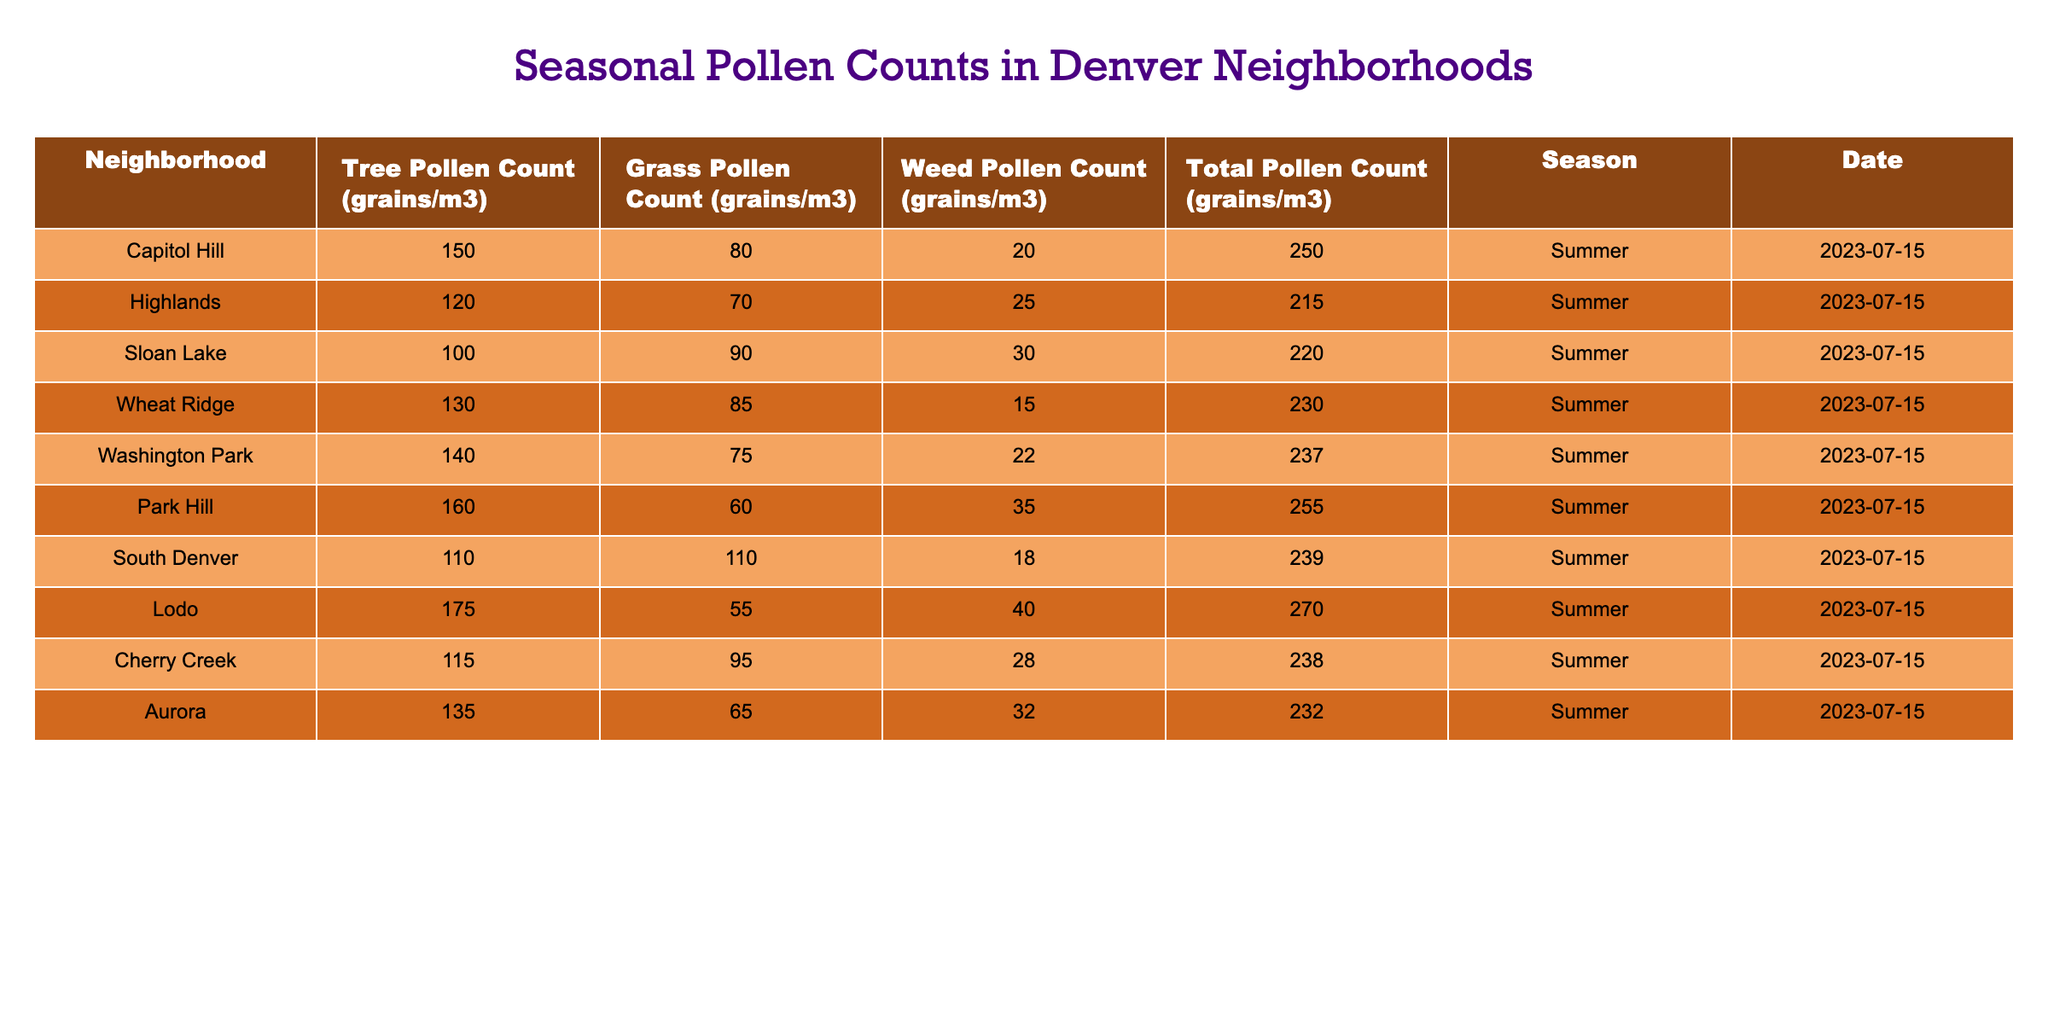What is the total pollen count for Park Hill? According to the table, the total pollen count for Park Hill is directly listed as 255 grains/m3.
Answer: 255 Which neighborhood has the highest tree pollen count? By checking the tree pollen counts in the table, Lodo has the highest count at 175 grains/m3.
Answer: Lodo What is the average total pollen count across all neighborhoods? To find the average total pollen count, first sum all the total counts: 250 + 215 + 220 + 230 + 237 + 255 + 239 + 270 + 238 + 232 =  2386. There are 10 neighborhoods, so the average is 2386 / 10 = 238.6.
Answer: 238.6 Is the grass pollen count for Sloan Lake less than 100 grains/m3? The grass pollen count for Sloan Lake is 90 grains/m3, which is less than 100 grains/m3. Therefore, the statement is true.
Answer: Yes Which neighborhood has both the lowest tree and highest weed pollen counts? Reviewing the table, the neighborhood with the lowest tree pollen count is Sloan Lake with 100 grains/m3, while the neighborhood with the highest weed pollen count is Lodo with 40 grains/m3. Thus, no neighborhood meets both criteria.
Answer: None 